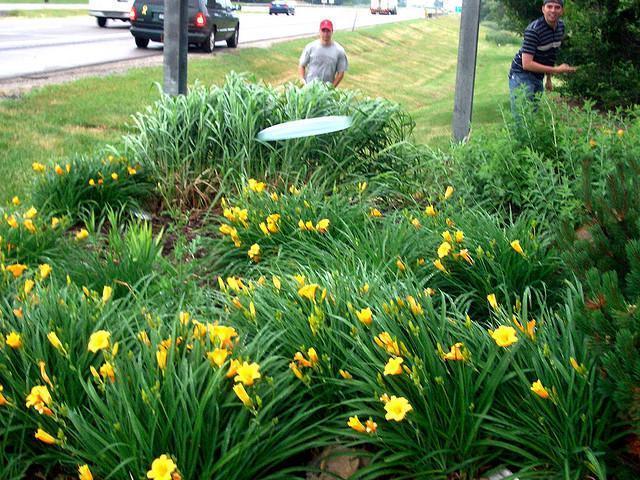How many purple flowers are there?
Give a very brief answer. 0. How many people are there?
Give a very brief answer. 2. 